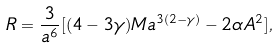<formula> <loc_0><loc_0><loc_500><loc_500>R = \frac { 3 } { a ^ { 6 } } [ ( 4 - 3 \gamma ) M a ^ { 3 ( 2 - \gamma ) } - 2 \alpha A ^ { 2 } ] ,</formula> 